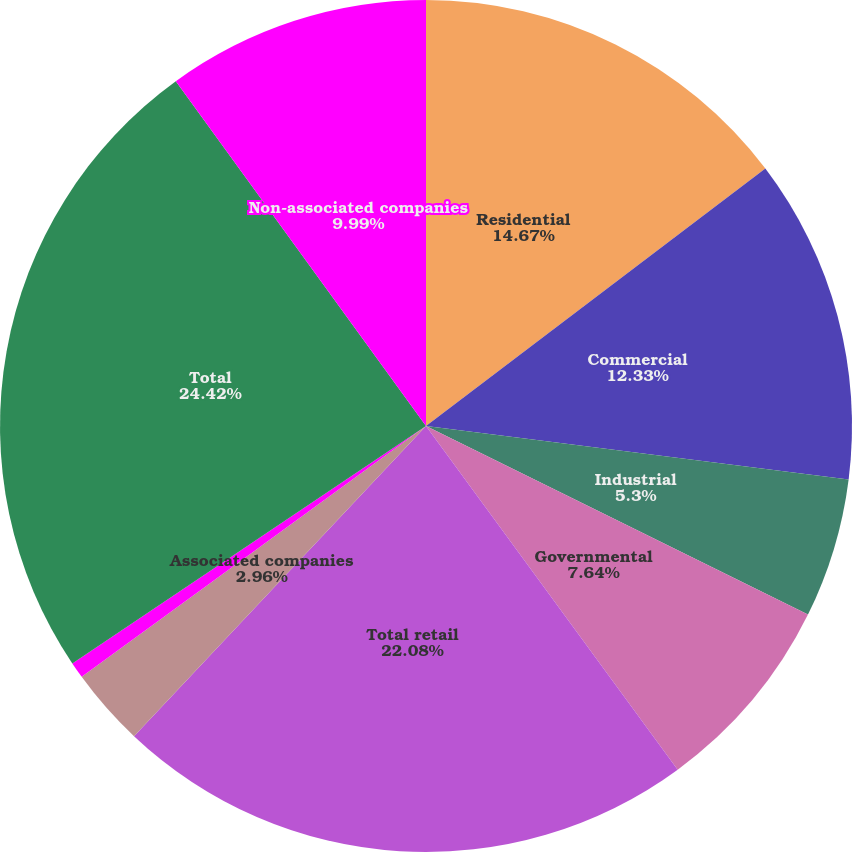Convert chart to OTSL. <chart><loc_0><loc_0><loc_500><loc_500><pie_chart><fcel>Residential<fcel>Commercial<fcel>Industrial<fcel>Governmental<fcel>Total retail<fcel>Associated companies<fcel>Other<fcel>Total<fcel>Non-associated companies<nl><fcel>14.67%<fcel>12.33%<fcel>5.3%<fcel>7.64%<fcel>22.08%<fcel>2.96%<fcel>0.61%<fcel>24.42%<fcel>9.99%<nl></chart> 